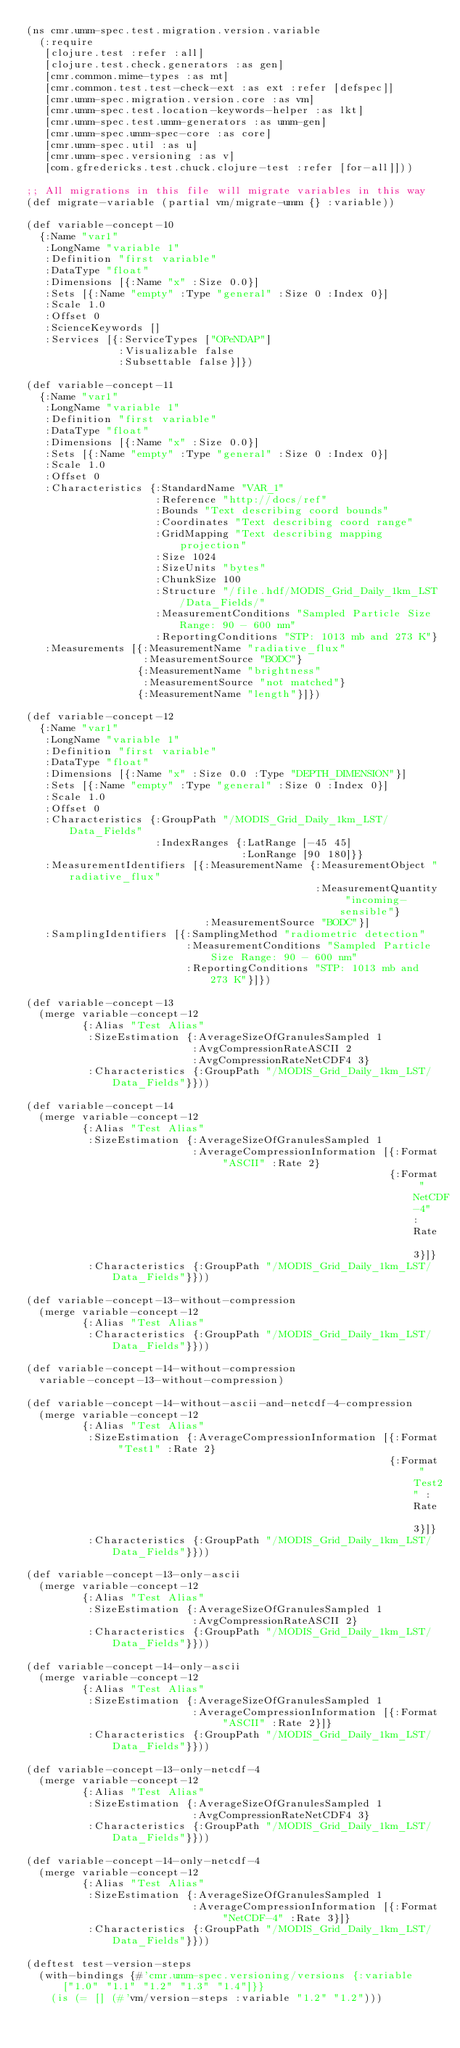Convert code to text. <code><loc_0><loc_0><loc_500><loc_500><_Clojure_>(ns cmr.umm-spec.test.migration.version.variable
  (:require
   [clojure.test :refer :all]
   [clojure.test.check.generators :as gen]
   [cmr.common.mime-types :as mt]
   [cmr.common.test.test-check-ext :as ext :refer [defspec]]
   [cmr.umm-spec.migration.version.core :as vm]
   [cmr.umm-spec.test.location-keywords-helper :as lkt]
   [cmr.umm-spec.test.umm-generators :as umm-gen]
   [cmr.umm-spec.umm-spec-core :as core]
   [cmr.umm-spec.util :as u]
   [cmr.umm-spec.versioning :as v]
   [com.gfredericks.test.chuck.clojure-test :refer [for-all]]))

;; All migrations in this file will migrate variables in this way
(def migrate-variable (partial vm/migrate-umm {} :variable))

(def variable-concept-10
  {:Name "var1"
   :LongName "variable 1"
   :Definition "first variable"
   :DataType "float"
   :Dimensions [{:Name "x" :Size 0.0}]
   :Sets [{:Name "empty" :Type "general" :Size 0 :Index 0}]
   :Scale 1.0
   :Offset 0
   :ScienceKeywords []
   :Services [{:ServiceTypes ["OPeNDAP"]
               :Visualizable false
               :Subsettable false}]})

(def variable-concept-11
  {:Name "var1"
   :LongName "variable 1"
   :Definition "first variable"
   :DataType "float"
   :Dimensions [{:Name "x" :Size 0.0}]
   :Sets [{:Name "empty" :Type "general" :Size 0 :Index 0}]
   :Scale 1.0
   :Offset 0
   :Characteristics {:StandardName "VAR_1"
                     :Reference "http://docs/ref"
                     :Bounds "Text describing coord bounds"
                     :Coordinates "Text describing coord range"
                     :GridMapping "Text describing mapping projection"
                     :Size 1024
                     :SizeUnits "bytes"
                     :ChunkSize 100
                     :Structure "/file.hdf/MODIS_Grid_Daily_1km_LST/Data_Fields/"
                     :MeasurementConditions "Sampled Particle Size Range: 90 - 600 nm"
                     :ReportingConditions "STP: 1013 mb and 273 K"}
   :Measurements [{:MeasurementName "radiative_flux"
                   :MeasurementSource "BODC"}
                  {:MeasurementName "brightness"
                   :MeasurementSource "not matched"}
                  {:MeasurementName "length"}]})

(def variable-concept-12
  {:Name "var1"
   :LongName "variable 1"
   :Definition "first variable"
   :DataType "float"
   :Dimensions [{:Name "x" :Size 0.0 :Type "DEPTH_DIMENSION"}]
   :Sets [{:Name "empty" :Type "general" :Size 0 :Index 0}]
   :Scale 1.0
   :Offset 0
   :Characteristics {:GroupPath "/MODIS_Grid_Daily_1km_LST/Data_Fields"
                     :IndexRanges {:LatRange [-45 45]
                                   :LonRange [90 180]}}
   :MeasurementIdentifiers [{:MeasurementName {:MeasurementObject "radiative_flux"
                                               :MeasurementQuantity "incoming-sensible"}
                             :MeasurementSource "BODC"}]
   :SamplingIdentifiers [{:SamplingMethod "radiometric detection"
                          :MeasurementConditions "Sampled Particle Size Range: 90 - 600 nm"
                          :ReportingConditions "STP: 1013 mb and 273 K"}]})

(def variable-concept-13
  (merge variable-concept-12
         {:Alias "Test Alias"
          :SizeEstimation {:AverageSizeOfGranulesSampled 1
                           :AvgCompressionRateASCII 2
                           :AvgCompressionRateNetCDF4 3}
          :Characteristics {:GroupPath "/MODIS_Grid_Daily_1km_LST/Data_Fields"}}))

(def variable-concept-14
  (merge variable-concept-12
         {:Alias "Test Alias"
          :SizeEstimation {:AverageSizeOfGranulesSampled 1
                           :AverageCompressionInformation [{:Format "ASCII" :Rate 2}
                                                           {:Format "NetCDF-4" :Rate 3}]}
          :Characteristics {:GroupPath "/MODIS_Grid_Daily_1km_LST/Data_Fields"}}))

(def variable-concept-13-without-compression
  (merge variable-concept-12
         {:Alias "Test Alias"
          :Characteristics {:GroupPath "/MODIS_Grid_Daily_1km_LST/Data_Fields"}}))

(def variable-concept-14-without-compression
  variable-concept-13-without-compression)

(def variable-concept-14-without-ascii-and-netcdf-4-compression
  (merge variable-concept-12
         {:Alias "Test Alias"
          :SizeEstimation {:AverageCompressionInformation [{:Format "Test1" :Rate 2}
                                                           {:Format "Test2" :Rate 3}]}
          :Characteristics {:GroupPath "/MODIS_Grid_Daily_1km_LST/Data_Fields"}}))

(def variable-concept-13-only-ascii
  (merge variable-concept-12
         {:Alias "Test Alias"
          :SizeEstimation {:AverageSizeOfGranulesSampled 1
                           :AvgCompressionRateASCII 2}
          :Characteristics {:GroupPath "/MODIS_Grid_Daily_1km_LST/Data_Fields"}}))

(def variable-concept-14-only-ascii
  (merge variable-concept-12
         {:Alias "Test Alias"
          :SizeEstimation {:AverageSizeOfGranulesSampled 1
                           :AverageCompressionInformation [{:Format "ASCII" :Rate 2}]}
          :Characteristics {:GroupPath "/MODIS_Grid_Daily_1km_LST/Data_Fields"}}))

(def variable-concept-13-only-netcdf-4
  (merge variable-concept-12
         {:Alias "Test Alias"
          :SizeEstimation {:AverageSizeOfGranulesSampled 1
                           :AvgCompressionRateNetCDF4 3}
          :Characteristics {:GroupPath "/MODIS_Grid_Daily_1km_LST/Data_Fields"}}))

(def variable-concept-14-only-netcdf-4
  (merge variable-concept-12
         {:Alias "Test Alias"
          :SizeEstimation {:AverageSizeOfGranulesSampled 1
                           :AverageCompressionInformation [{:Format "NetCDF-4" :Rate 3}]}
          :Characteristics {:GroupPath "/MODIS_Grid_Daily_1km_LST/Data_Fields"}}))

(deftest test-version-steps
  (with-bindings {#'cmr.umm-spec.versioning/versions {:variable ["1.0" "1.1" "1.2" "1.3" "1.4"]}}
    (is (= [] (#'vm/version-steps :variable "1.2" "1.2")))</code> 